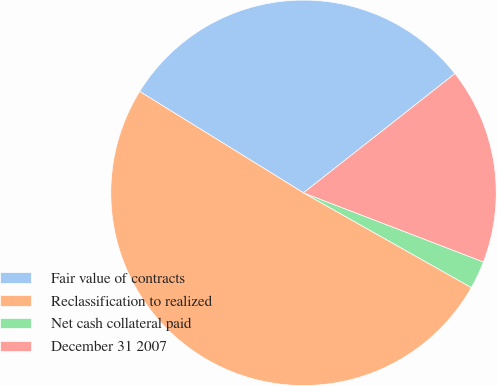Convert chart to OTSL. <chart><loc_0><loc_0><loc_500><loc_500><pie_chart><fcel>Fair value of contracts<fcel>Reclassification to realized<fcel>Net cash collateral paid<fcel>December 31 2007<nl><fcel>30.57%<fcel>50.64%<fcel>2.34%<fcel>16.45%<nl></chart> 